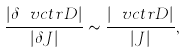Convert formula to latex. <formula><loc_0><loc_0><loc_500><loc_500>\frac { | \delta \ v c t r { D } | } { | \delta J | } \sim \frac { | \ v c t r { D } | } { | J | } ,</formula> 